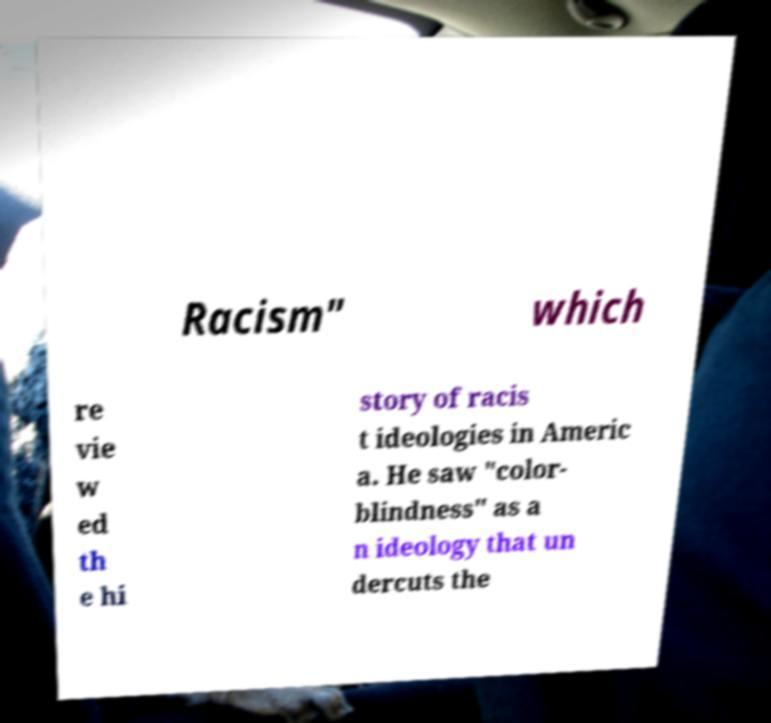Could you extract and type out the text from this image? Racism" which re vie w ed th e hi story of racis t ideologies in Americ a. He saw "color- blindness" as a n ideology that un dercuts the 